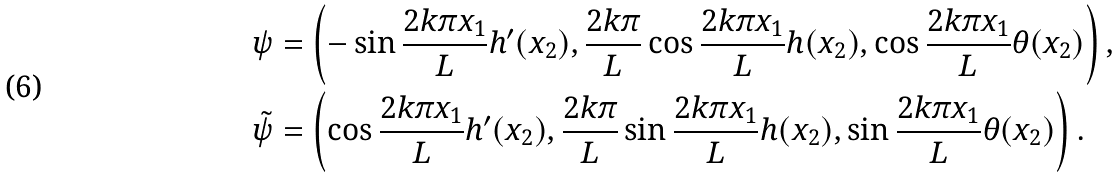<formula> <loc_0><loc_0><loc_500><loc_500>& \psi = \left ( - \sin \frac { 2 k \pi x _ { 1 } } { L } h ^ { \prime } ( x _ { 2 } ) , \frac { 2 k \pi } { L } \cos \frac { 2 k \pi x _ { 1 } } { L } h ( x _ { 2 } ) , \cos \frac { 2 k \pi x _ { 1 } } { L } \theta ( x _ { 2 } ) \right ) , \\ & \tilde { \psi } = \left ( \cos \frac { 2 k \pi x _ { 1 } } { L } h ^ { \prime } ( x _ { 2 } ) , \frac { 2 k \pi } { L } \sin \frac { 2 k \pi x _ { 1 } } { L } h ( x _ { 2 } ) , \sin \frac { 2 k \pi x _ { 1 } } { L } \theta ( x _ { 2 } ) \right ) .</formula> 